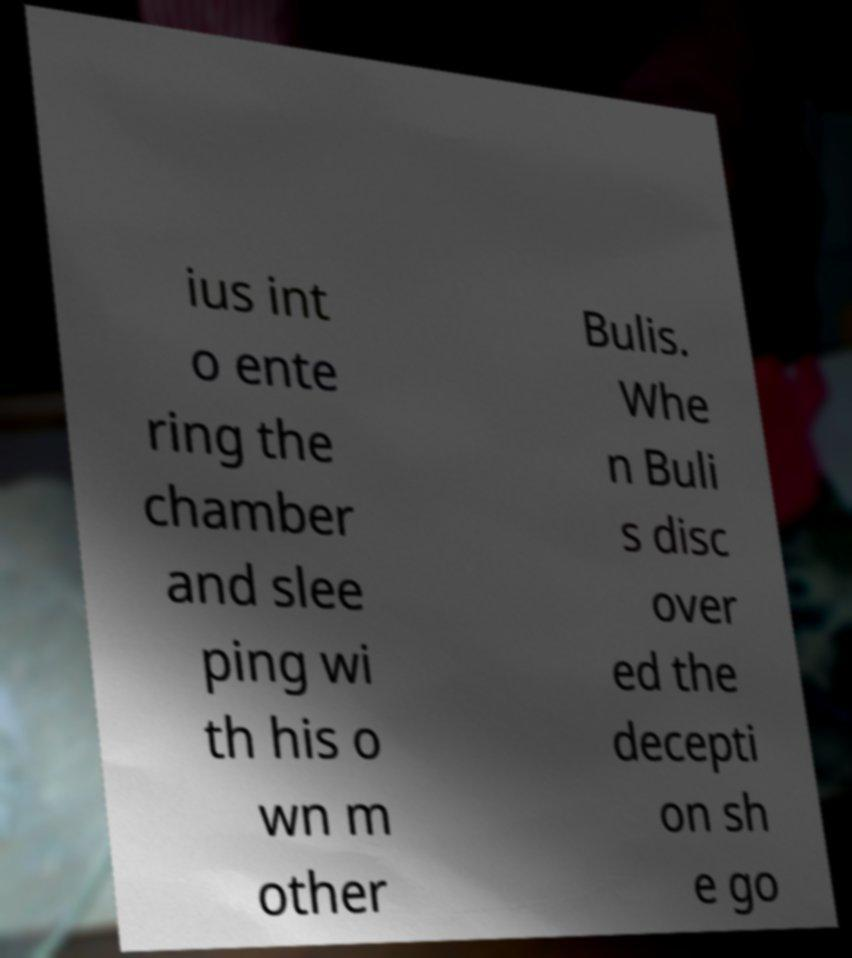Could you assist in decoding the text presented in this image and type it out clearly? ius int o ente ring the chamber and slee ping wi th his o wn m other Bulis. Whe n Buli s disc over ed the decepti on sh e go 